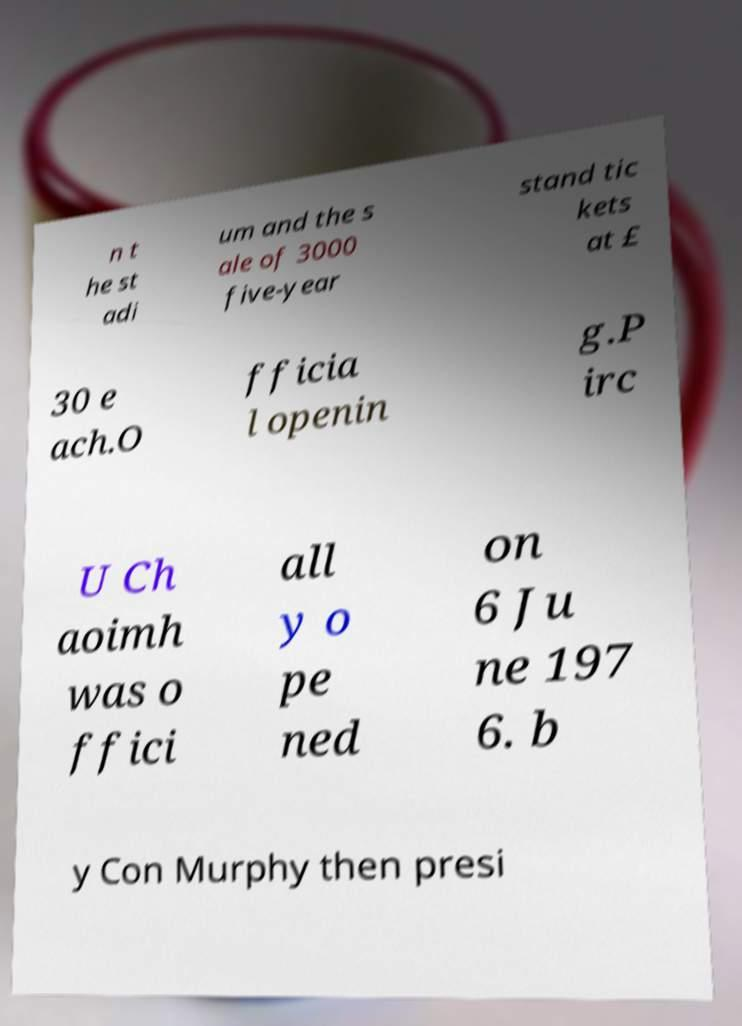What messages or text are displayed in this image? I need them in a readable, typed format. n t he st adi um and the s ale of 3000 five-year stand tic kets at £ 30 e ach.O fficia l openin g.P irc U Ch aoimh was o ffici all y o pe ned on 6 Ju ne 197 6. b y Con Murphy then presi 